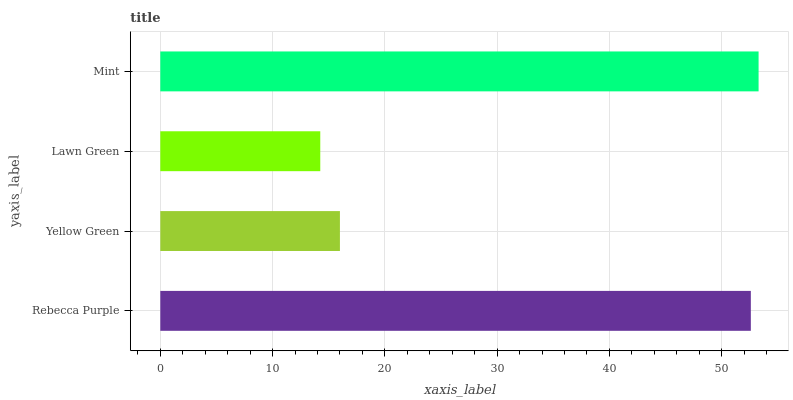Is Lawn Green the minimum?
Answer yes or no. Yes. Is Mint the maximum?
Answer yes or no. Yes. Is Yellow Green the minimum?
Answer yes or no. No. Is Yellow Green the maximum?
Answer yes or no. No. Is Rebecca Purple greater than Yellow Green?
Answer yes or no. Yes. Is Yellow Green less than Rebecca Purple?
Answer yes or no. Yes. Is Yellow Green greater than Rebecca Purple?
Answer yes or no. No. Is Rebecca Purple less than Yellow Green?
Answer yes or no. No. Is Rebecca Purple the high median?
Answer yes or no. Yes. Is Yellow Green the low median?
Answer yes or no. Yes. Is Mint the high median?
Answer yes or no. No. Is Mint the low median?
Answer yes or no. No. 